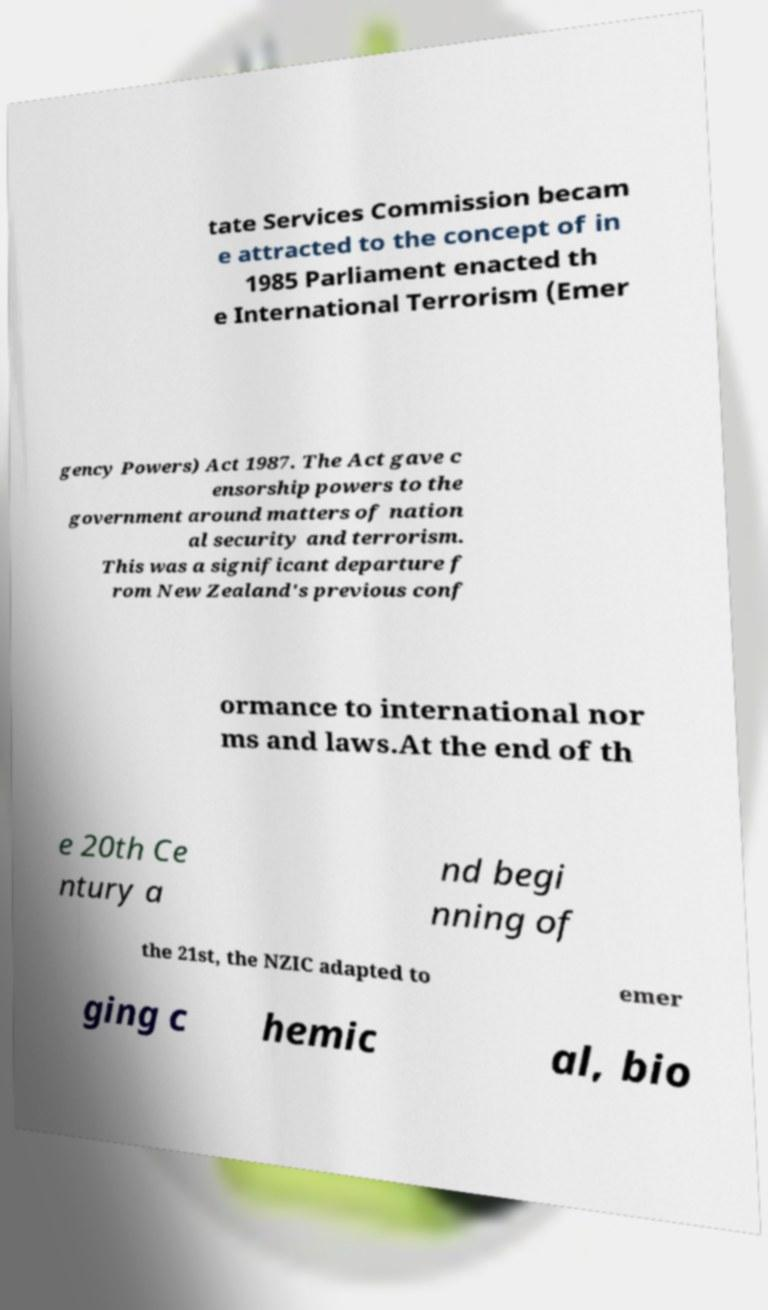Could you assist in decoding the text presented in this image and type it out clearly? tate Services Commission becam e attracted to the concept of in 1985 Parliament enacted th e International Terrorism (Emer gency Powers) Act 1987. The Act gave c ensorship powers to the government around matters of nation al security and terrorism. This was a significant departure f rom New Zealand's previous conf ormance to international nor ms and laws.At the end of th e 20th Ce ntury a nd begi nning of the 21st, the NZIC adapted to emer ging c hemic al, bio 